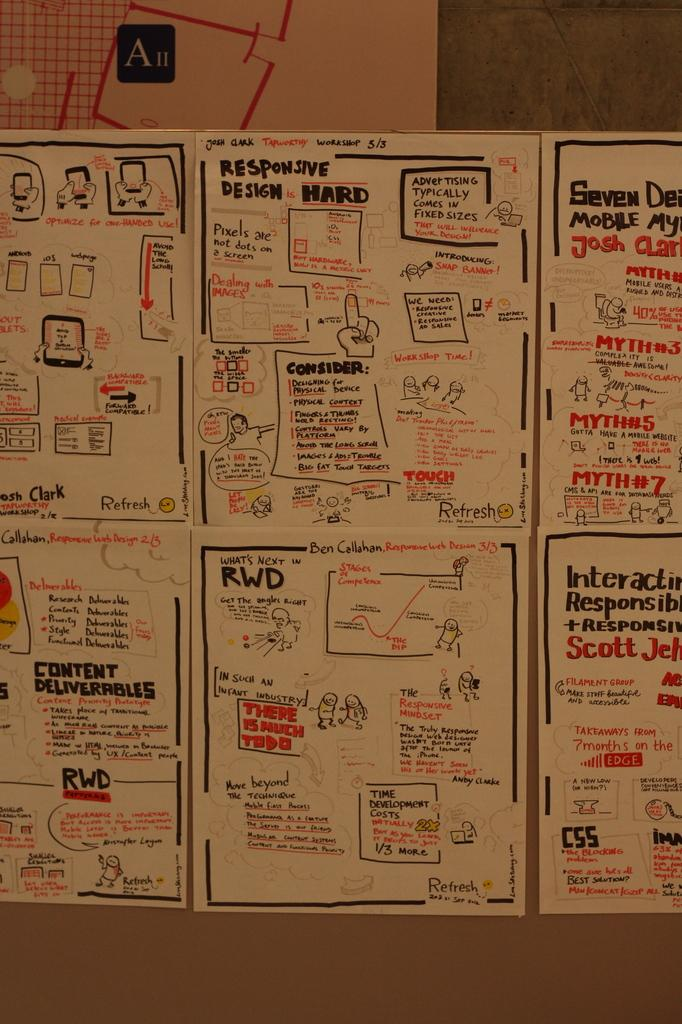<image>
Present a compact description of the photo's key features. Handwritten posted signs about Responsive Design is Hard and other game development cartoons and directions. 